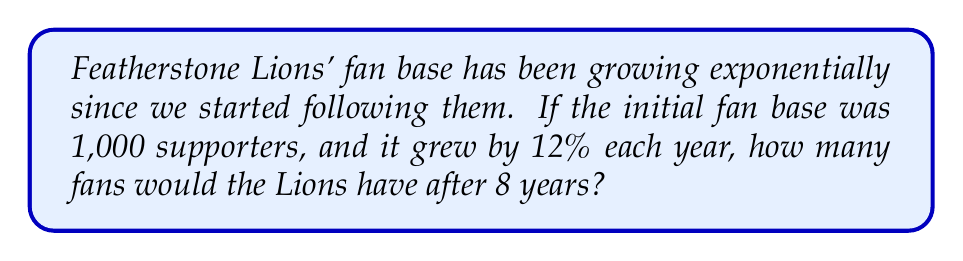Can you answer this question? Let's approach this step-by-step:

1) The initial number of fans is 1,000.
2) The growth rate is 12% per year, which we can express as 1.12 (100% + 12% = 112% = 1.12).
3) We need to calculate this growth over 8 years.

We can use the exponential growth formula:

$$A = P(1 + r)^t$$

Where:
$A$ = Final amount
$P$ = Initial principal balance
$r$ = Annual growth rate (in decimal form)
$t$ = Number of years

Plugging in our values:

$$A = 1000(1 + 0.12)^8$$
$$A = 1000(1.12)^8$$

Now, let's calculate:

$$A = 1000 * 2.4758$$
$$A = 2475.8$$

Rounding to the nearest whole number (as we can't have a fraction of a person):

$$A ≈ 2476$$

Therefore, after 8 years, the Featherstone Lions would have approximately 2,476 fans.
Answer: 2,476 fans 